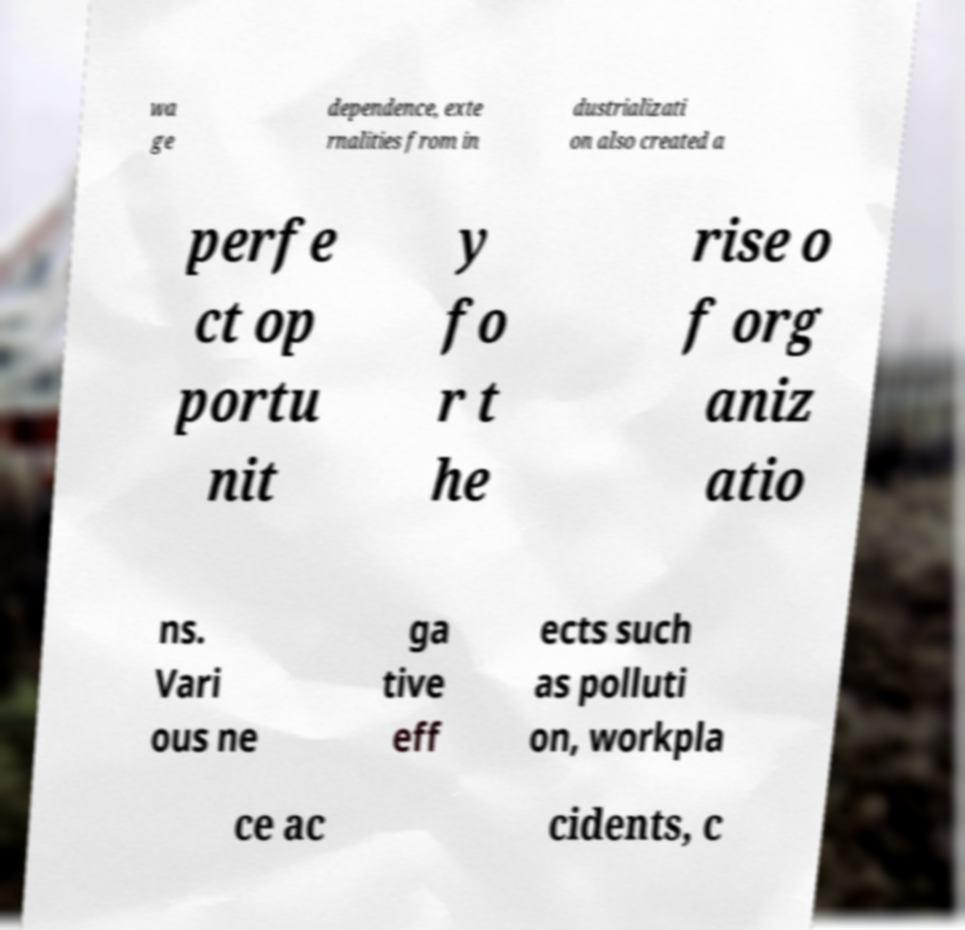Can you accurately transcribe the text from the provided image for me? wa ge dependence, exte rnalities from in dustrializati on also created a perfe ct op portu nit y fo r t he rise o f org aniz atio ns. Vari ous ne ga tive eff ects such as polluti on, workpla ce ac cidents, c 